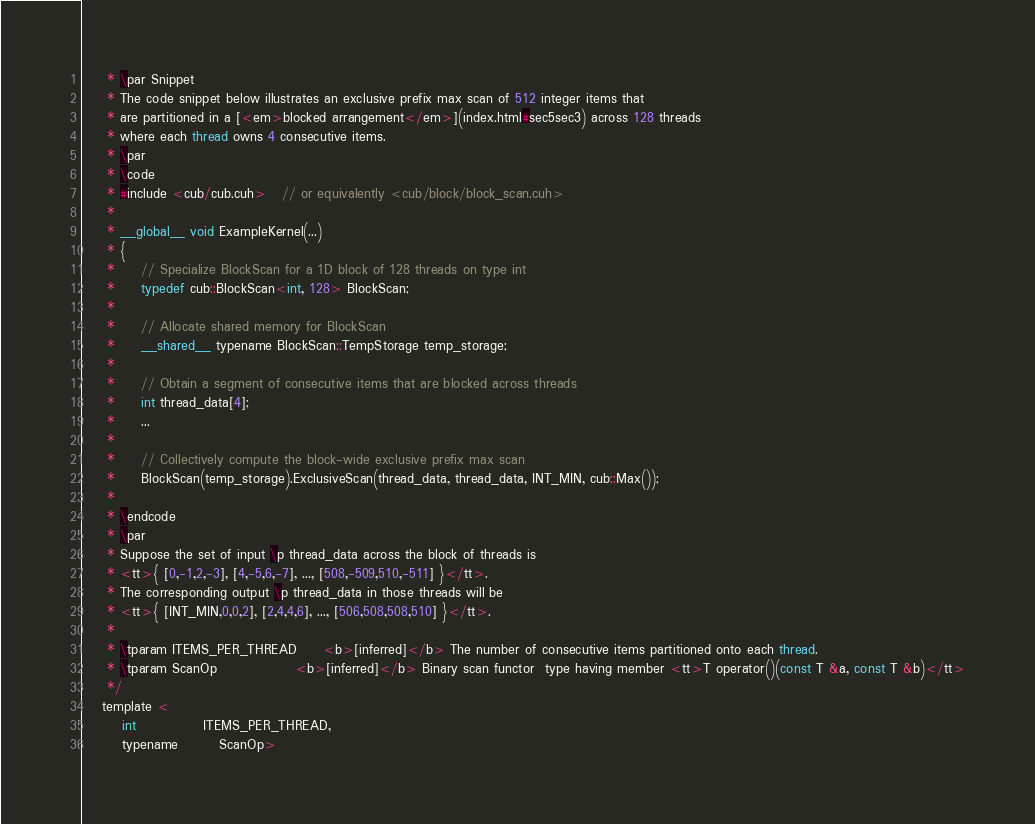Convert code to text. <code><loc_0><loc_0><loc_500><loc_500><_Cuda_>     * \par Snippet
     * The code snippet below illustrates an exclusive prefix max scan of 512 integer items that
     * are partitioned in a [<em>blocked arrangement</em>](index.html#sec5sec3) across 128 threads
     * where each thread owns 4 consecutive items.
     * \par
     * \code
     * #include <cub/cub.cuh>   // or equivalently <cub/block/block_scan.cuh>
     *
     * __global__ void ExampleKernel(...)
     * {
     *     // Specialize BlockScan for a 1D block of 128 threads on type int
     *     typedef cub::BlockScan<int, 128> BlockScan;
     *
     *     // Allocate shared memory for BlockScan
     *     __shared__ typename BlockScan::TempStorage temp_storage;
     *
     *     // Obtain a segment of consecutive items that are blocked across threads
     *     int thread_data[4];
     *     ...
     *
     *     // Collectively compute the block-wide exclusive prefix max scan
     *     BlockScan(temp_storage).ExclusiveScan(thread_data, thread_data, INT_MIN, cub::Max());
     *
     * \endcode
     * \par
     * Suppose the set of input \p thread_data across the block of threads is
     * <tt>{ [0,-1,2,-3], [4,-5,6,-7], ..., [508,-509,510,-511] }</tt>.
     * The corresponding output \p thread_data in those threads will be
     * <tt>{ [INT_MIN,0,0,2], [2,4,4,6], ..., [506,508,508,510] }</tt>.
     *
     * \tparam ITEMS_PER_THREAD     <b>[inferred]</b> The number of consecutive items partitioned onto each thread.
     * \tparam ScanOp               <b>[inferred]</b> Binary scan functor  type having member <tt>T operator()(const T &a, const T &b)</tt>
     */
    template <
        int             ITEMS_PER_THREAD,
        typename        ScanOp></code> 